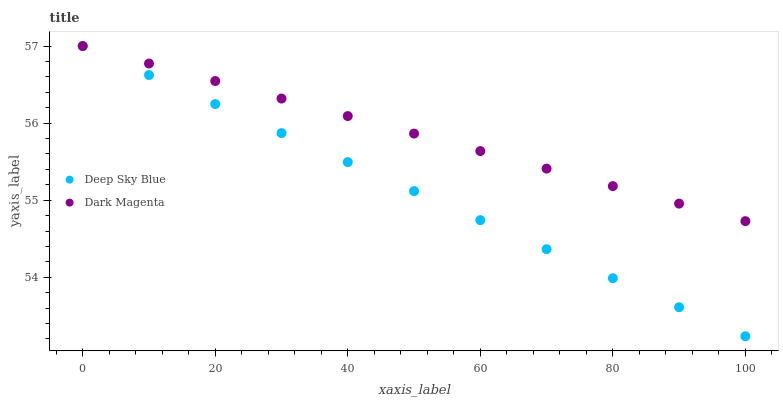Does Deep Sky Blue have the minimum area under the curve?
Answer yes or no. Yes. Does Dark Magenta have the maximum area under the curve?
Answer yes or no. Yes. Does Deep Sky Blue have the maximum area under the curve?
Answer yes or no. No. Is Dark Magenta the smoothest?
Answer yes or no. Yes. Is Deep Sky Blue the roughest?
Answer yes or no. Yes. Is Deep Sky Blue the smoothest?
Answer yes or no. No. Does Deep Sky Blue have the lowest value?
Answer yes or no. Yes. Does Deep Sky Blue have the highest value?
Answer yes or no. Yes. Does Deep Sky Blue intersect Dark Magenta?
Answer yes or no. Yes. Is Deep Sky Blue less than Dark Magenta?
Answer yes or no. No. Is Deep Sky Blue greater than Dark Magenta?
Answer yes or no. No. 